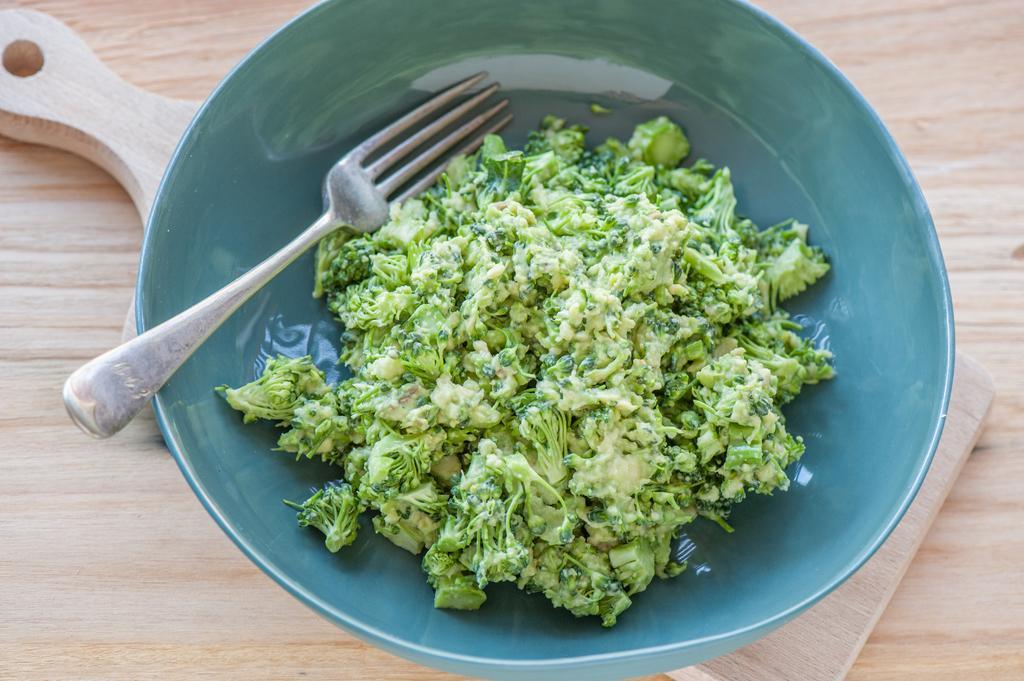Please provide a concise description of this image. In this image I can see the food in the bowl and the food is in green color and I also a fork and the bowl is on the wooden surface. 